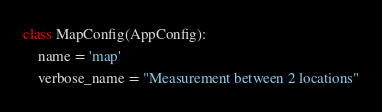Convert code to text. <code><loc_0><loc_0><loc_500><loc_500><_Python_>
class MapConfig(AppConfig):
    name = 'map'
    verbose_name = "Measurement between 2 locations"
</code> 